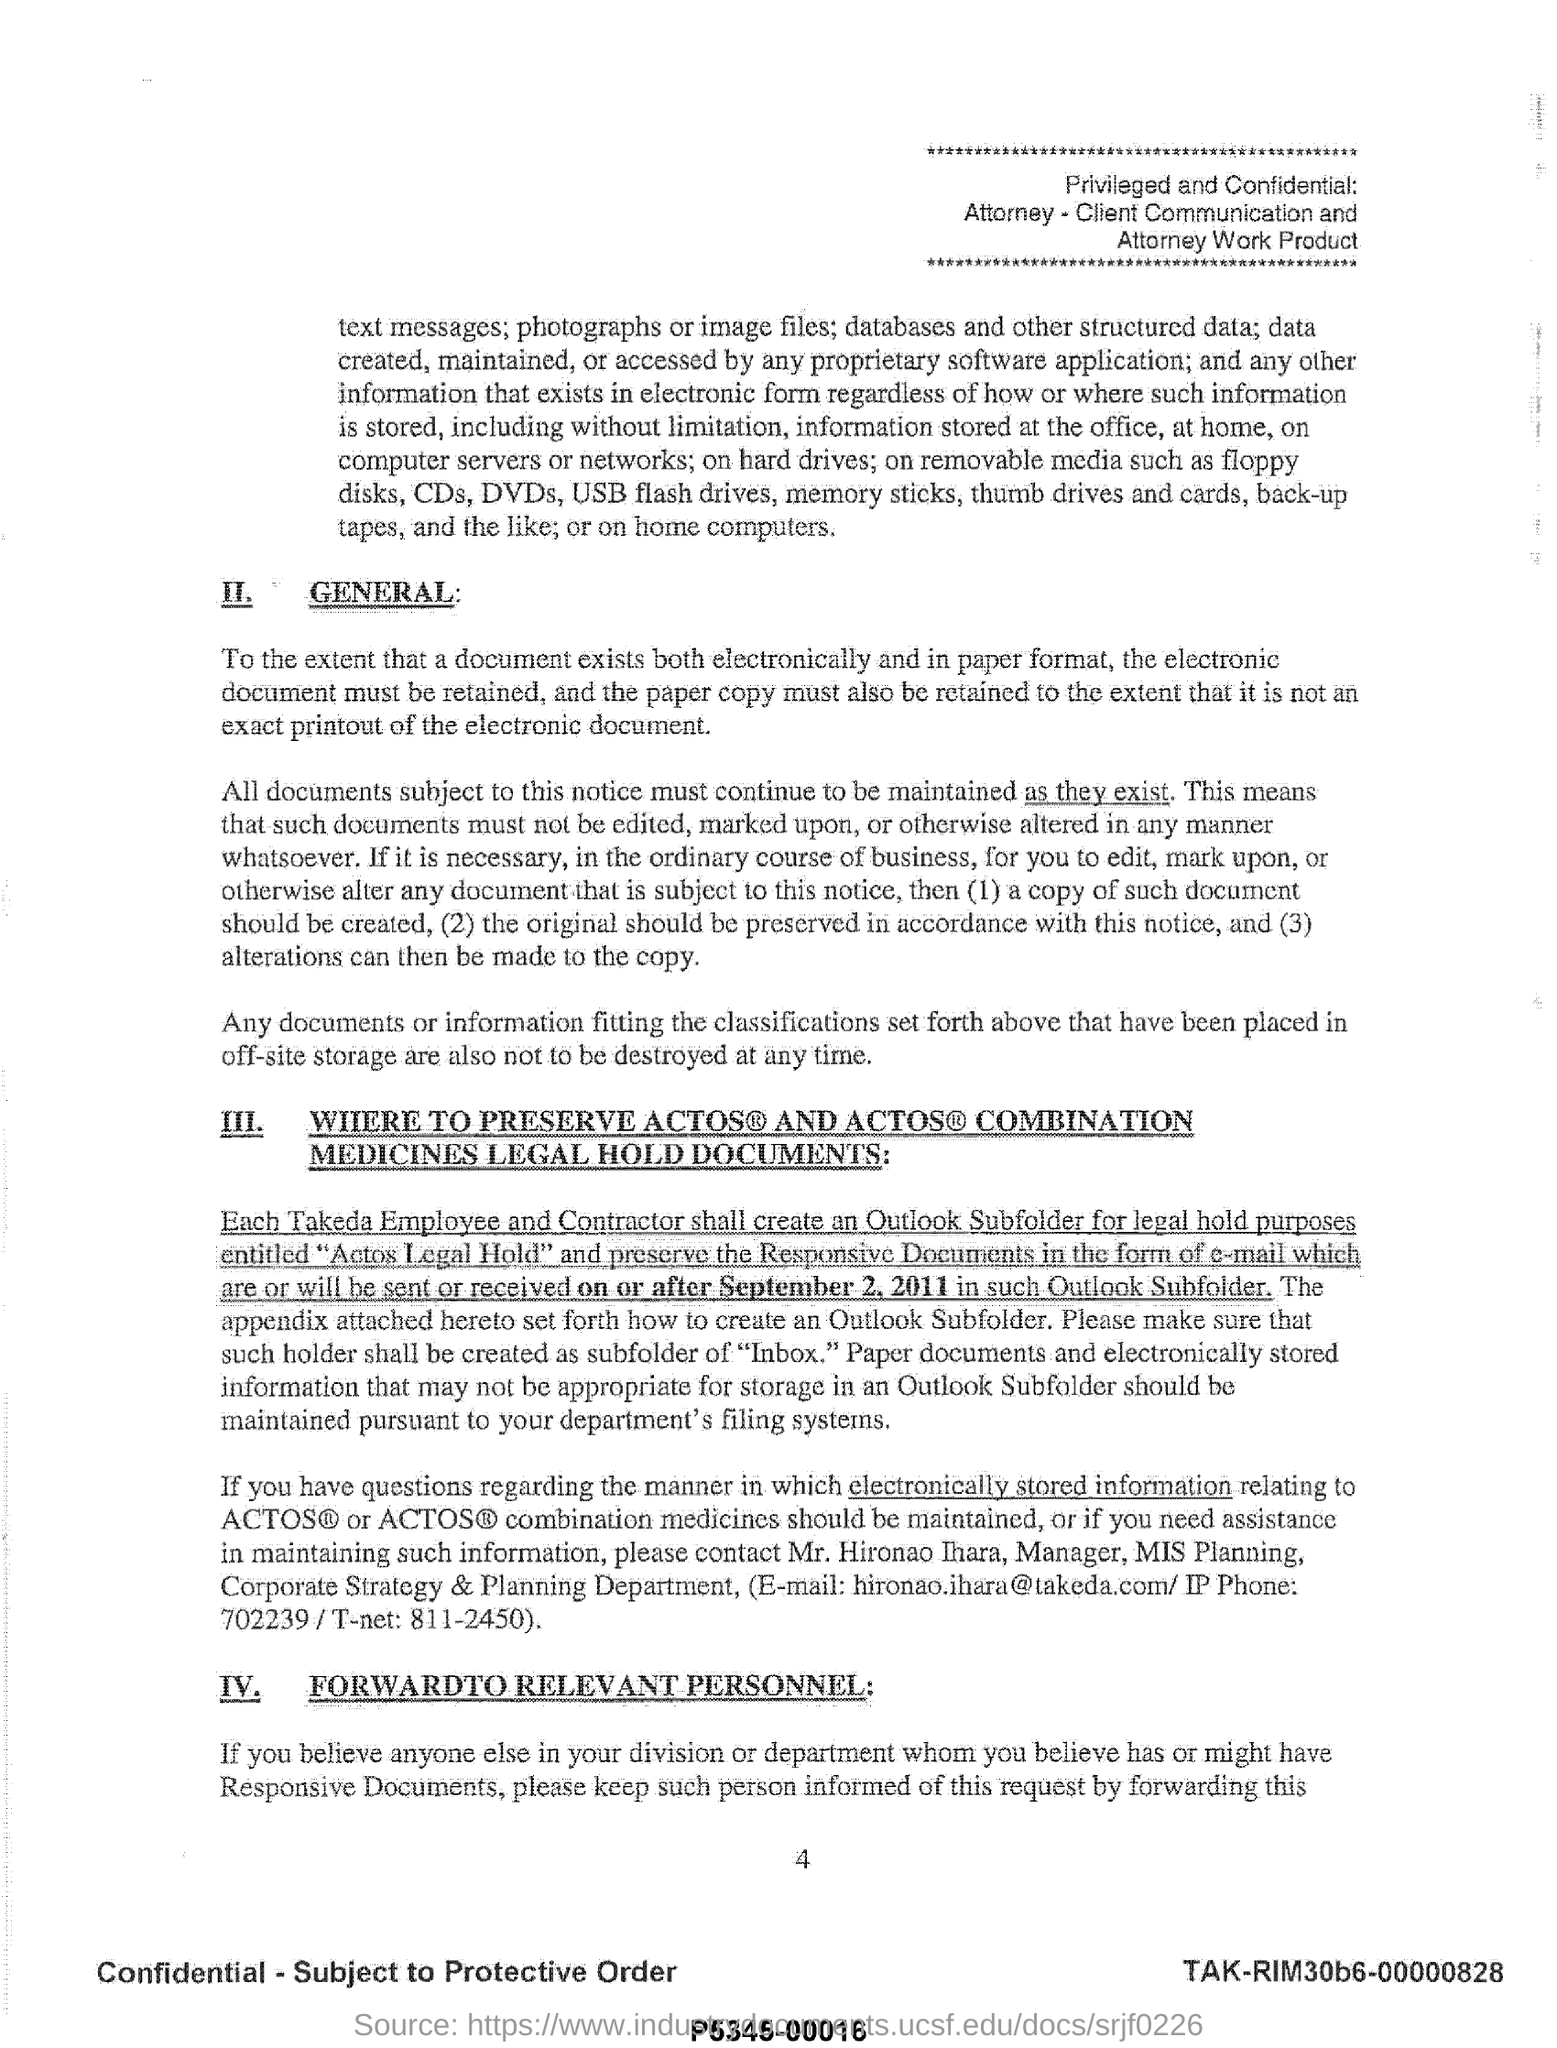Who is the Manager of MIS planning?
Keep it short and to the point. Mr. Hironao Ihara. What is the email id of Mr. Hironao Ihara?
Provide a short and direct response. Hironao.ihara@takeda.com. What is the IP phone no of Mr. Hironao Ihara?
Your response must be concise. 702239. 